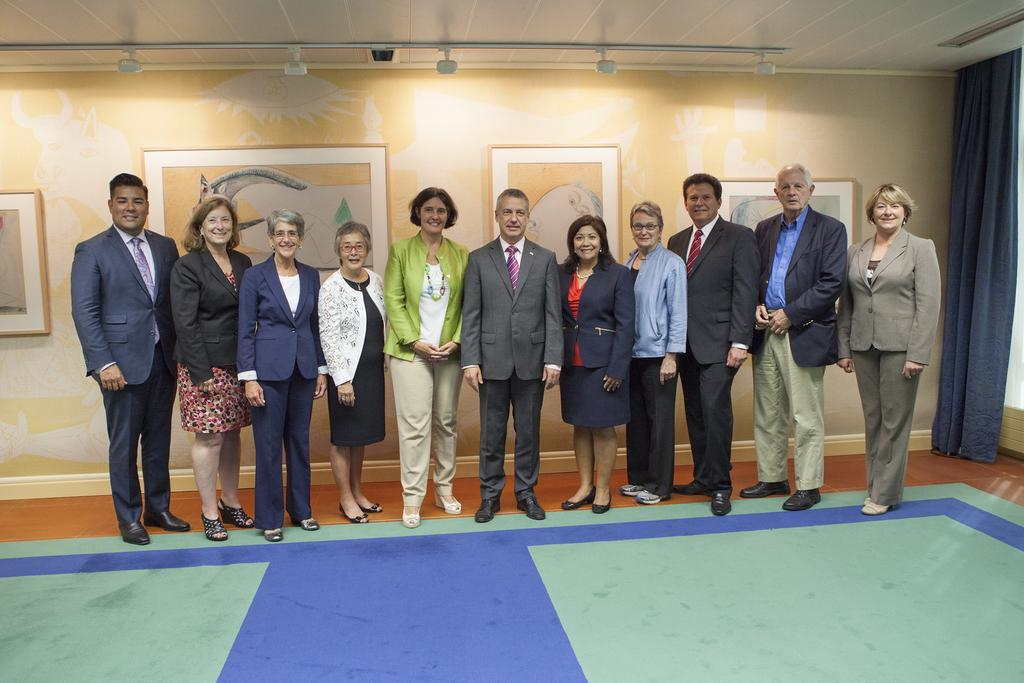How many people are in the image? There is a group of people standing in the image. What is located behind the group of people? There is a wall in the image. What can be seen hanging on the wall? There are photo frames in the image. What is on the floor in front of the group of people? There is a mat in the image. What type of window treatment is present in the image? There is a curtain in the image. What type of coil is used to divide the room in the image? There is no coil present in the image, nor is there any indication of the room being divided. 